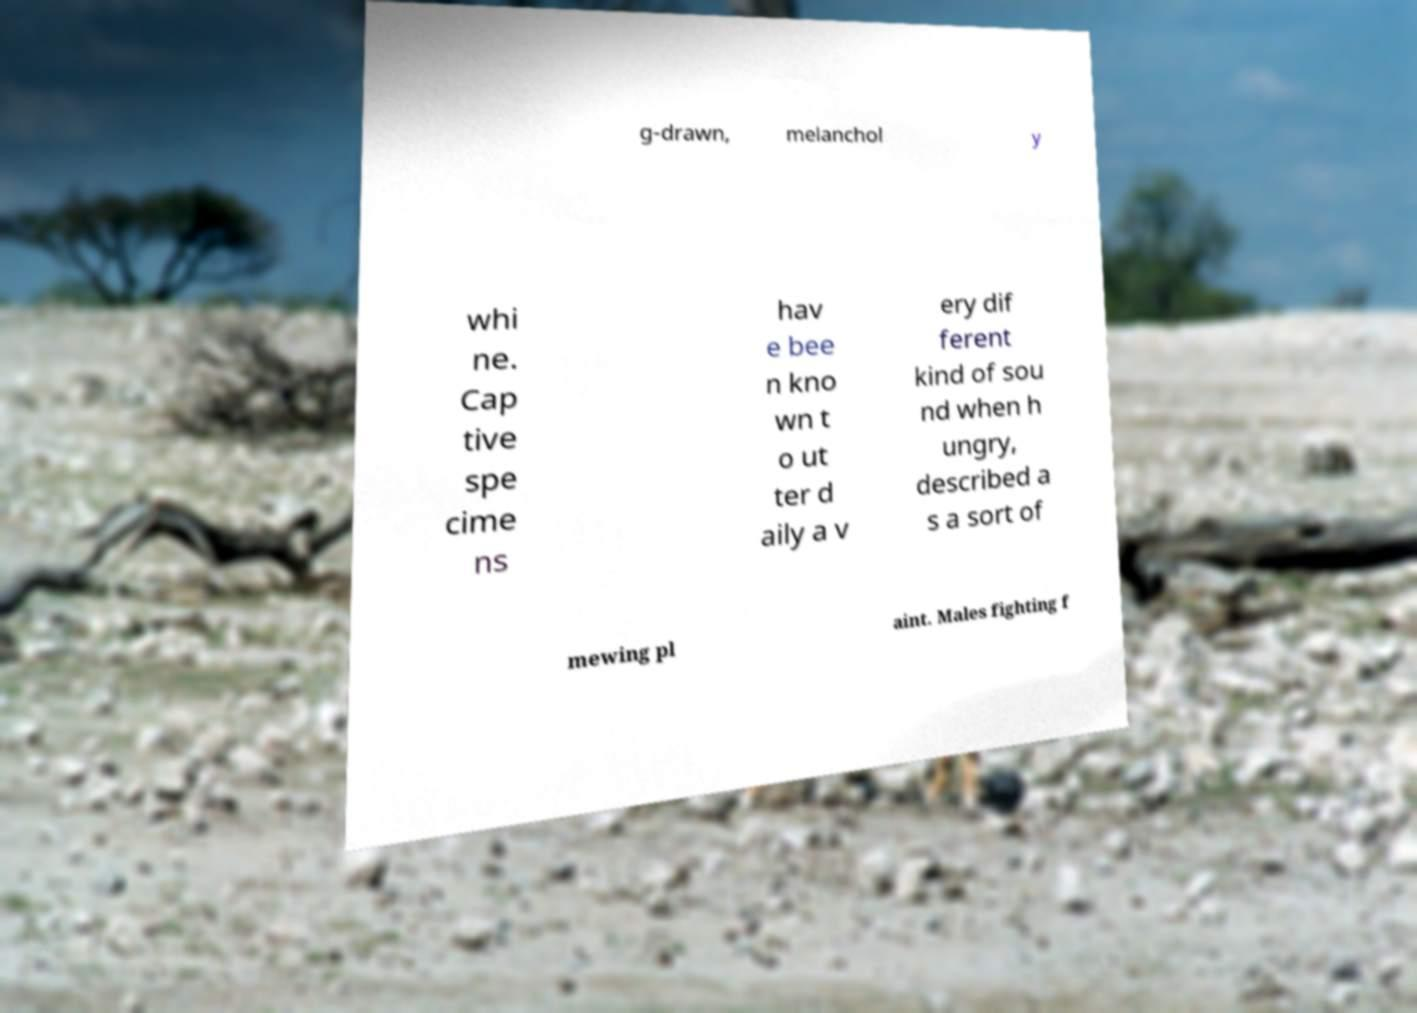There's text embedded in this image that I need extracted. Can you transcribe it verbatim? g-drawn, melanchol y whi ne. Cap tive spe cime ns hav e bee n kno wn t o ut ter d aily a v ery dif ferent kind of sou nd when h ungry, described a s a sort of mewing pl aint. Males fighting f 